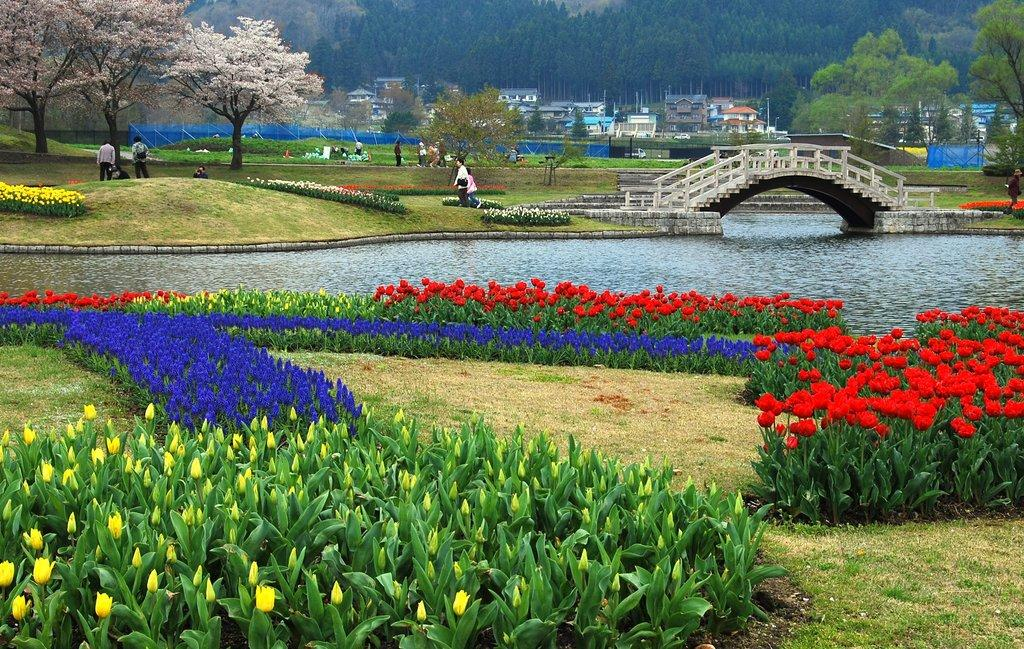What type of structure can be seen in the image? There is a walkway bridge in the image. What can be found near the bridge in the image? Flower beds are present in the image. What type of vegetation is visible in the image? Trees are visible in the image. What type of man-made structures are in the image? There are buildings in the image. What is the location of the persons in the image? Persons are on the ground in the image. What type of cows can be seen grazing in the flower beds in the image? There are no cows present in the image; it features a walkway bridge, flower beds, trees, buildings, and persons on the ground. What time of day is it in the image, based on the stomachs of the persons? There is no information about the time of day or the stomachs of the persons in the image. 